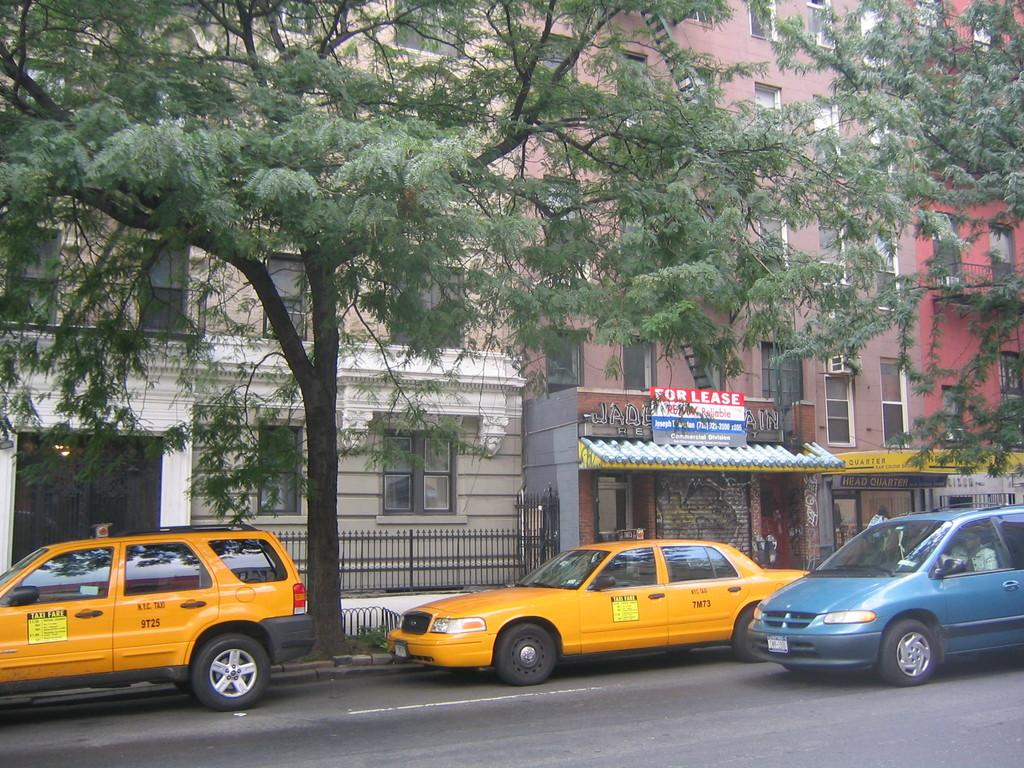<image>
Create a compact narrative representing the image presented. a building for lease has a cab sitting in front of it 